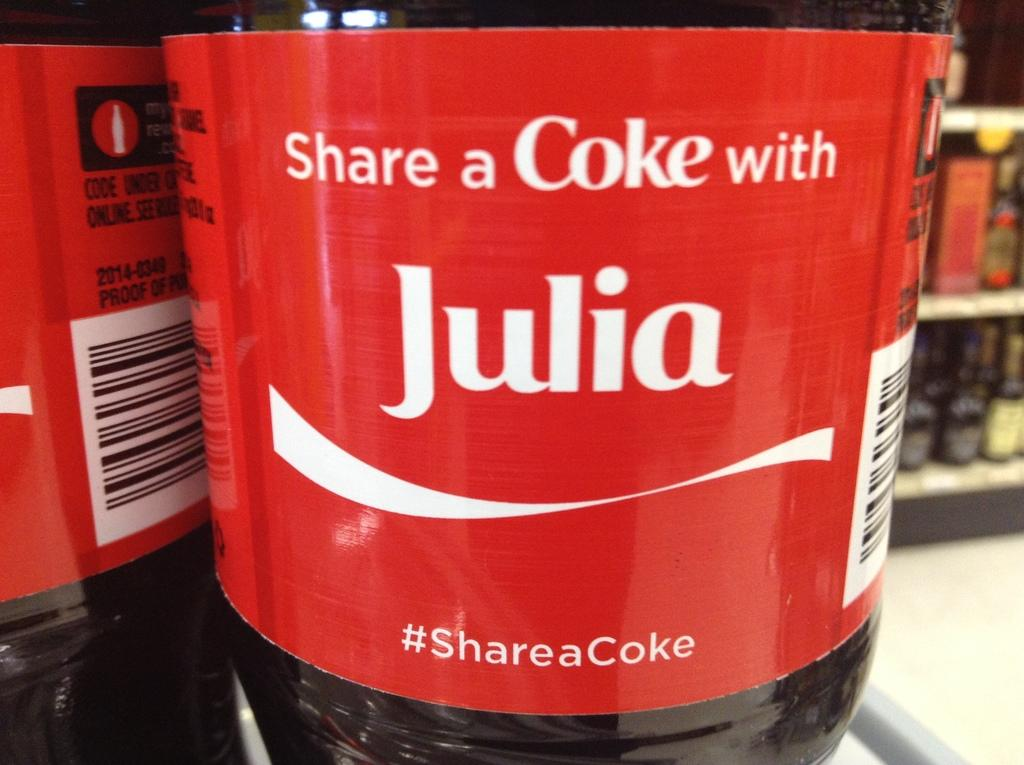<image>
Relay a brief, clear account of the picture shown. A two liter with a red label saying Share a Coke with Julia. 